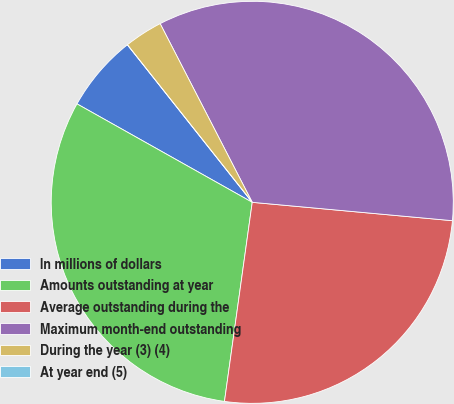Convert chart. <chart><loc_0><loc_0><loc_500><loc_500><pie_chart><fcel>In millions of dollars<fcel>Amounts outstanding at year<fcel>Average outstanding during the<fcel>Maximum month-end outstanding<fcel>During the year (3) (4)<fcel>At year end (5)<nl><fcel>6.19%<fcel>30.94%<fcel>25.75%<fcel>34.03%<fcel>3.09%<fcel>0.0%<nl></chart> 